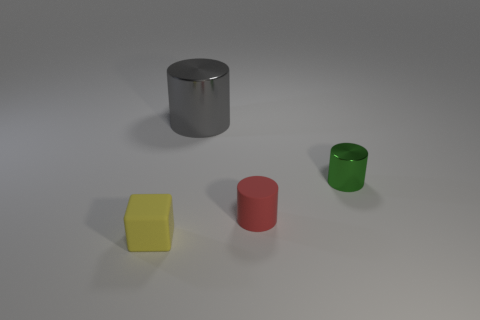Add 2 purple matte cubes. How many objects exist? 6 Subtract all blocks. How many objects are left? 3 Add 2 yellow objects. How many yellow objects exist? 3 Subtract 0 purple spheres. How many objects are left? 4 Subtract all tiny green shiny cylinders. Subtract all tiny rubber cylinders. How many objects are left? 2 Add 1 large cylinders. How many large cylinders are left? 2 